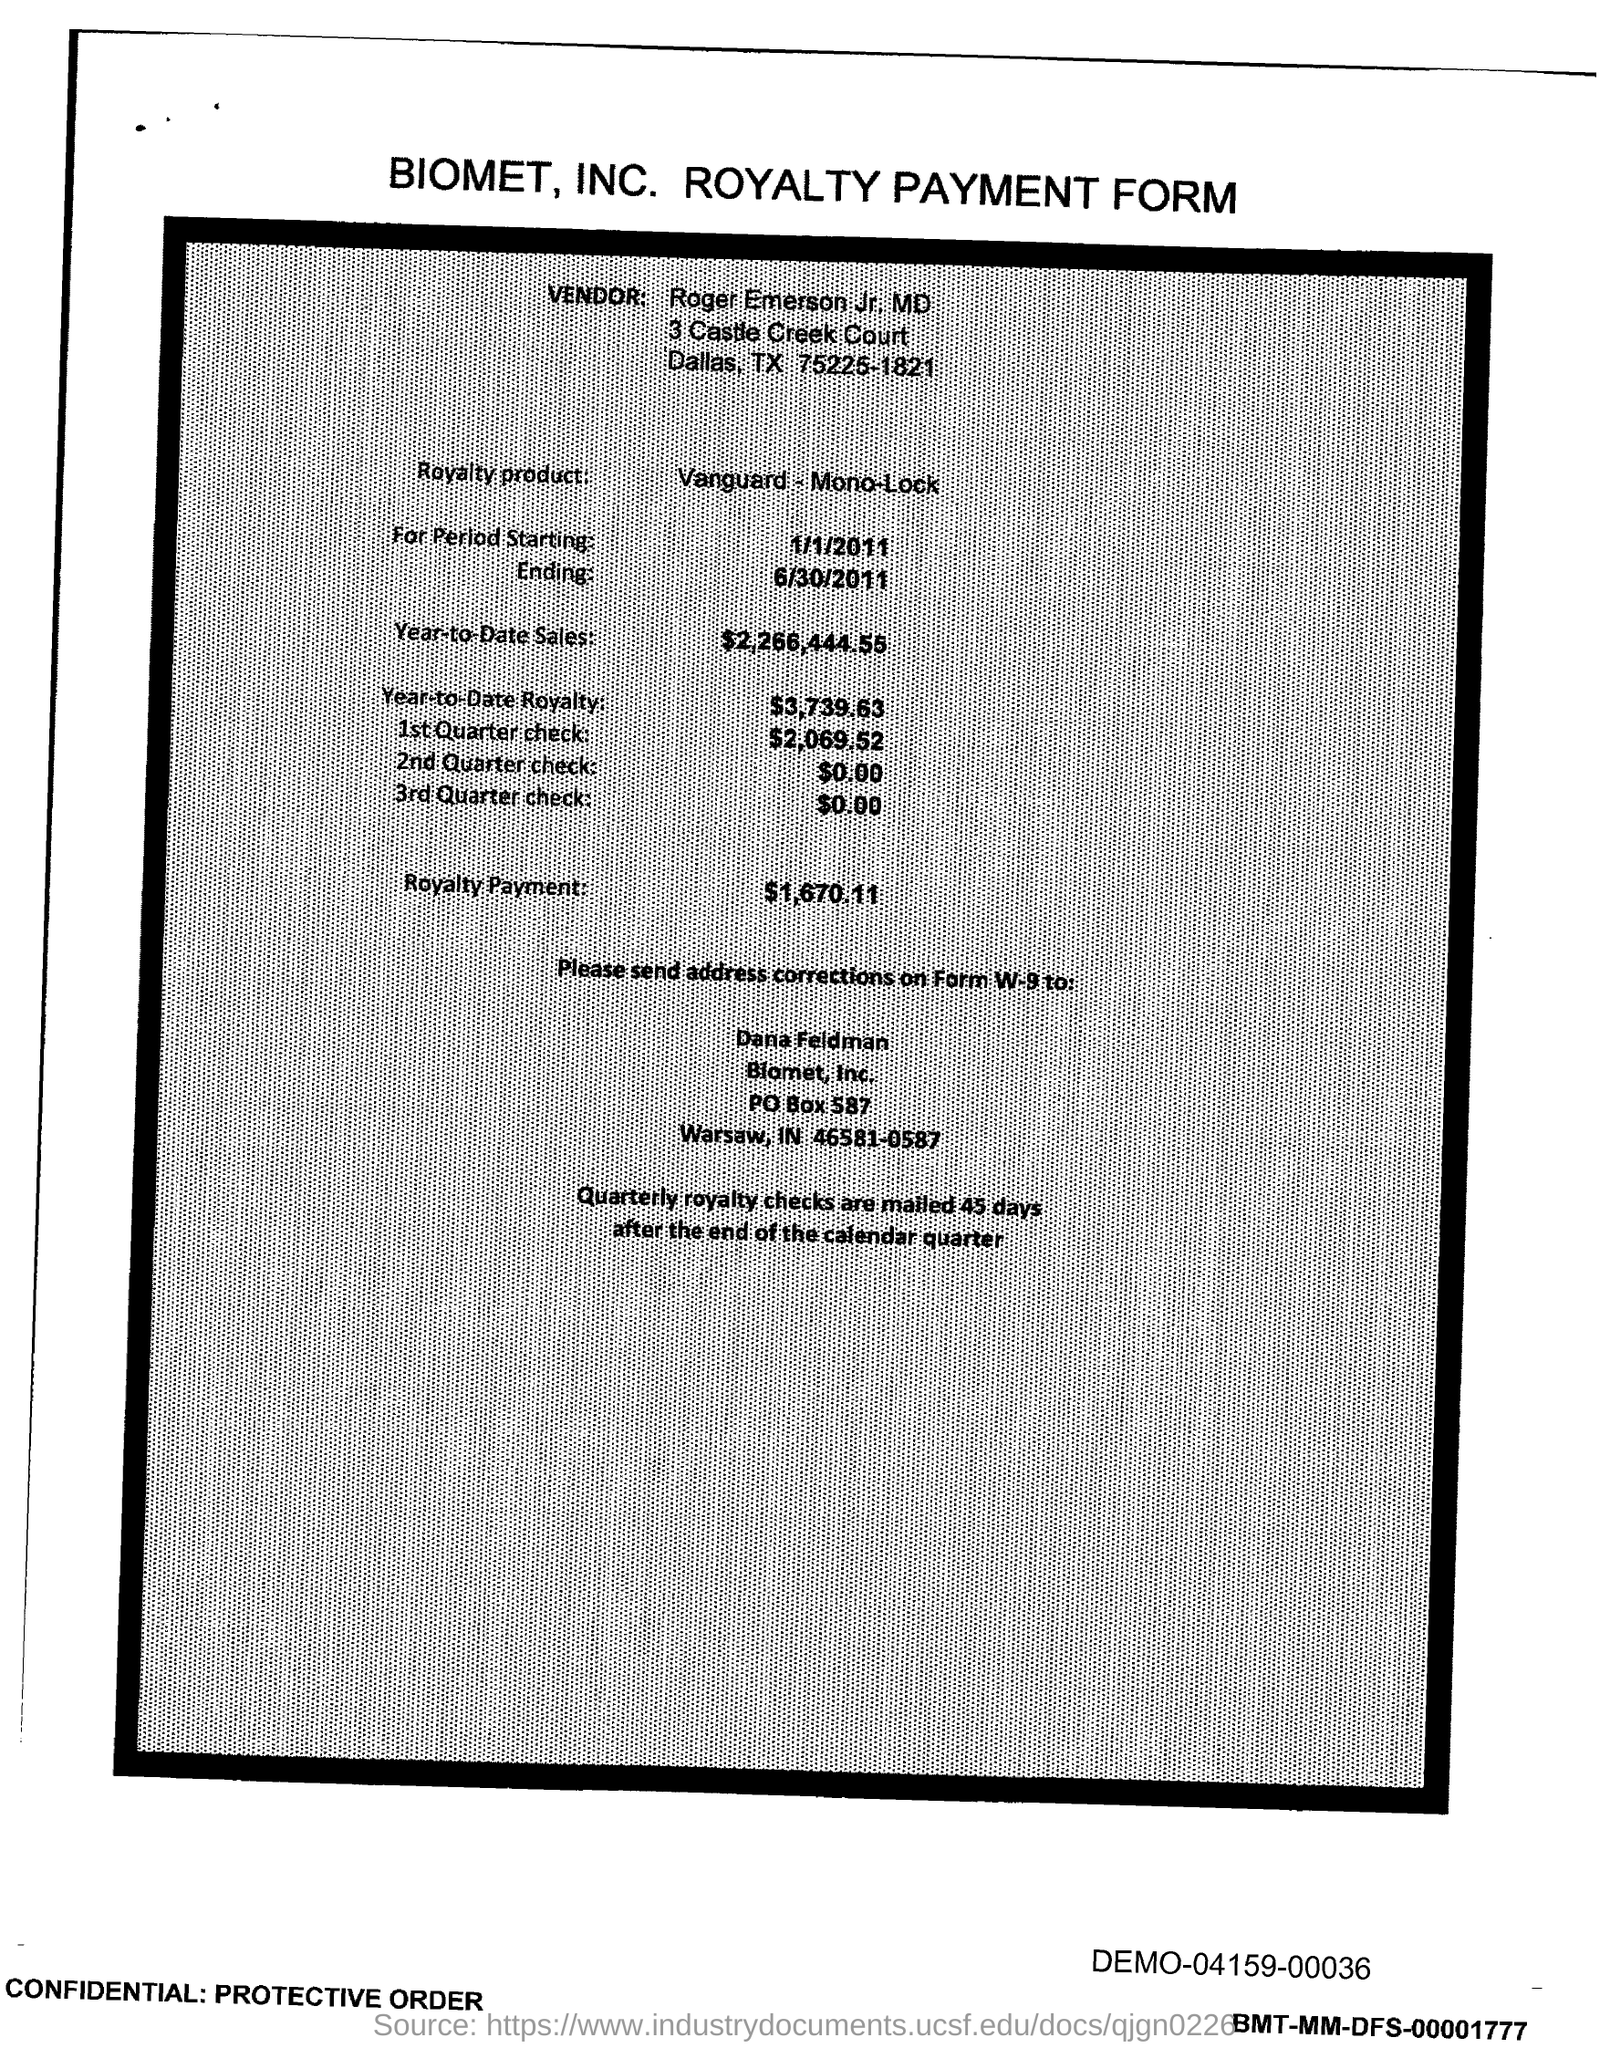Highlight a few significant elements in this photo. The royalty product is given in the form of Vanguard, Mono, and Lock. The year-to-date royalty for the product is $3,739.63. Quarterly royalty checks are mailed 45 days after the end of the calendar quarter. Roger Emerson is the vendor mentioned in the form. The royalty payment form in question is from Biomet, Inc. 